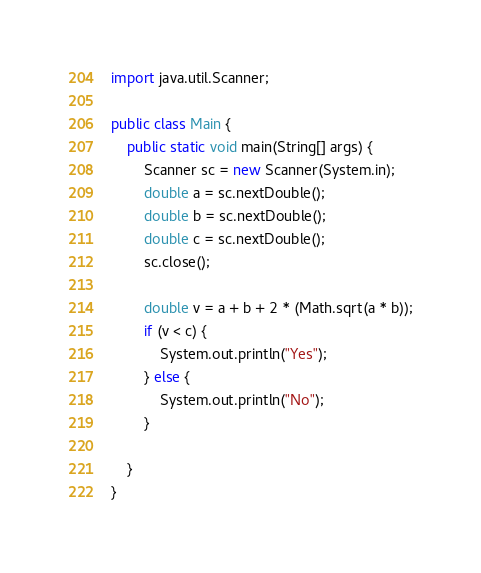<code> <loc_0><loc_0><loc_500><loc_500><_Java_>import java.util.Scanner;

public class Main {
	public static void main(String[] args) {
		Scanner sc = new Scanner(System.in);
		double a = sc.nextDouble();
		double b = sc.nextDouble();
		double c = sc.nextDouble();
		sc.close();

		double v = a + b + 2 * (Math.sqrt(a * b));
		if (v < c) {
			System.out.println("Yes");
		} else {
			System.out.println("No");
		}

	}
}
</code> 